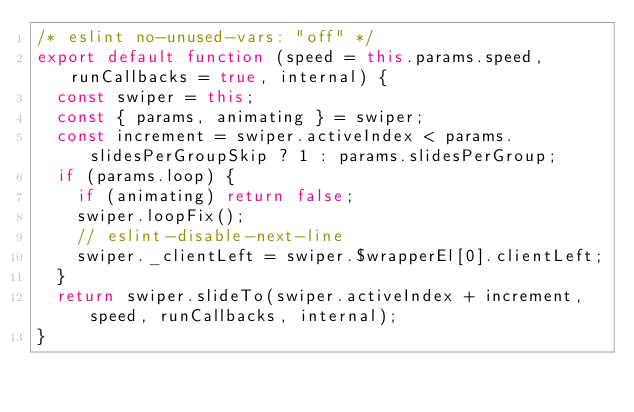<code> <loc_0><loc_0><loc_500><loc_500><_JavaScript_>/* eslint no-unused-vars: "off" */
export default function (speed = this.params.speed, runCallbacks = true, internal) {
  const swiper = this;
  const { params, animating } = swiper;
  const increment = swiper.activeIndex < params.slidesPerGroupSkip ? 1 : params.slidesPerGroup;
  if (params.loop) {
    if (animating) return false;
    swiper.loopFix();
    // eslint-disable-next-line
    swiper._clientLeft = swiper.$wrapperEl[0].clientLeft;
  }
  return swiper.slideTo(swiper.activeIndex + increment, speed, runCallbacks, internal);
}
</code> 